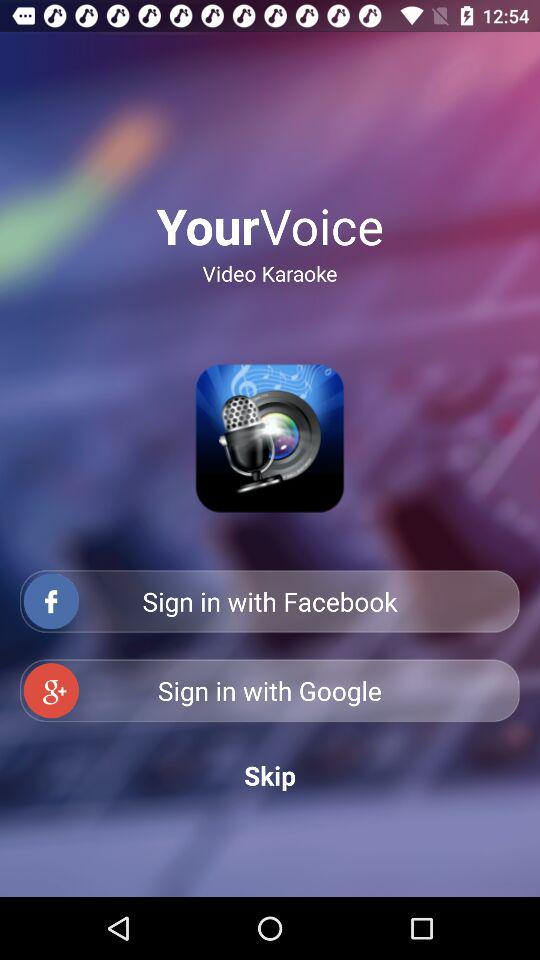What are the sign-in options? The sign-in options are "Facebook" and "Google". 